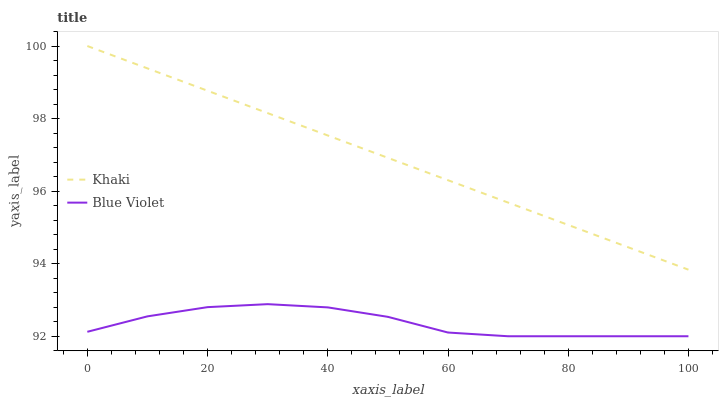Does Blue Violet have the minimum area under the curve?
Answer yes or no. Yes. Does Khaki have the maximum area under the curve?
Answer yes or no. Yes. Does Blue Violet have the maximum area under the curve?
Answer yes or no. No. Is Khaki the smoothest?
Answer yes or no. Yes. Is Blue Violet the roughest?
Answer yes or no. Yes. Is Blue Violet the smoothest?
Answer yes or no. No. Does Khaki have the highest value?
Answer yes or no. Yes. Does Blue Violet have the highest value?
Answer yes or no. No. Is Blue Violet less than Khaki?
Answer yes or no. Yes. Is Khaki greater than Blue Violet?
Answer yes or no. Yes. Does Blue Violet intersect Khaki?
Answer yes or no. No. 